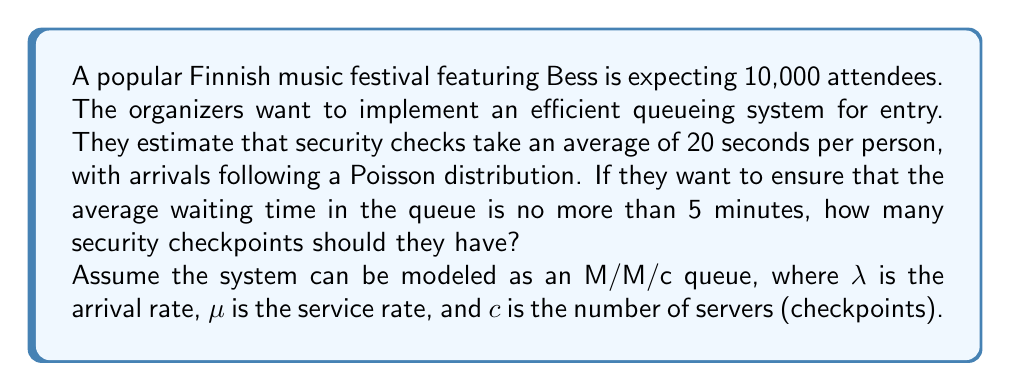Show me your answer to this math problem. To solve this problem, we'll use the M/M/c queueing model and follow these steps:

1. Calculate the arrival rate (λ):
   Assuming attendees arrive over a 2-hour period:
   λ = 10,000 / (2 * 60 * 60) ≈ 1.39 persons/second

2. Calculate the service rate (μ):
   μ = 1 / 20 = 0.05 persons/second

3. Use the M/M/c queue formula for average waiting time in the queue:

   $$W_q = \frac{P_0(λ/μ)^c}{c!(c-ρ)^2} \cdot \frac{1}{cμ-λ}$$

   Where:
   - $W_q$ is the average waiting time in the queue
   - $P_0$ is the probability of an empty system
   - $ρ = λ/(cμ)$ is the utilization factor

4. We want $W_q ≤ 5$ minutes = 300 seconds

5. Solve the equation iteratively for c:

   Start with c = λ/μ = 1.39/0.05 ≈ 28 (rounded up)

   Increase c until $W_q ≤ 300$ seconds

   Using a calculator or computer program, we find that c = 30 gives $W_q ≈ 299.8$ seconds

Therefore, the festival needs at least 30 security checkpoints to keep the average waiting time under 5 minutes.
Answer: 30 security checkpoints 